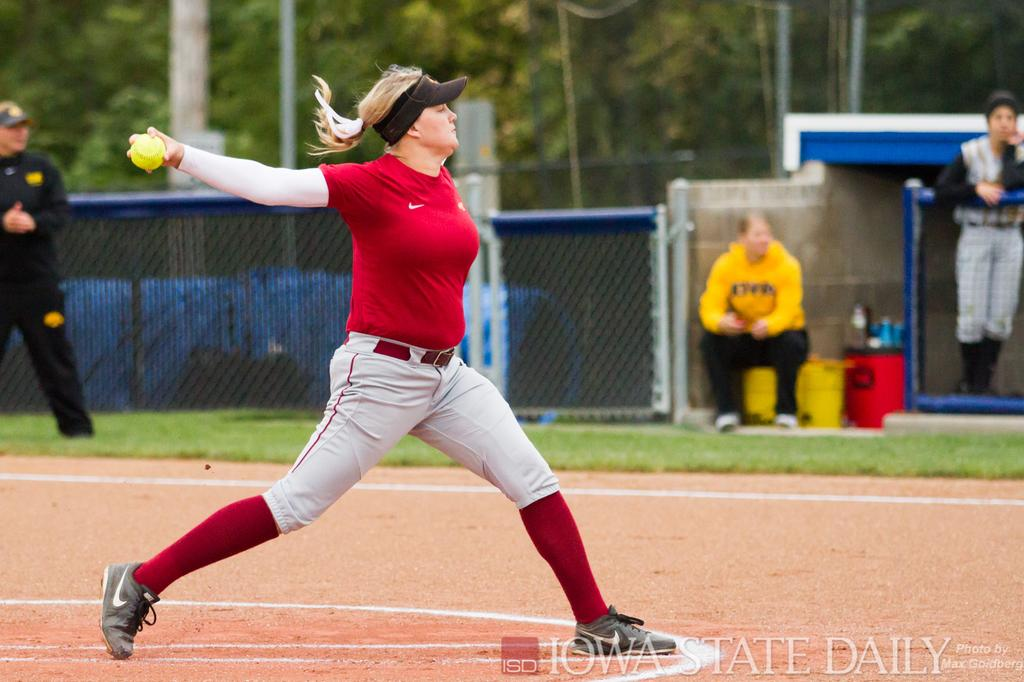<image>
Create a compact narrative representing the image presented. WOman wearing a red shirt pitching a ball with the words "Iow State Daily" on the bottom. 